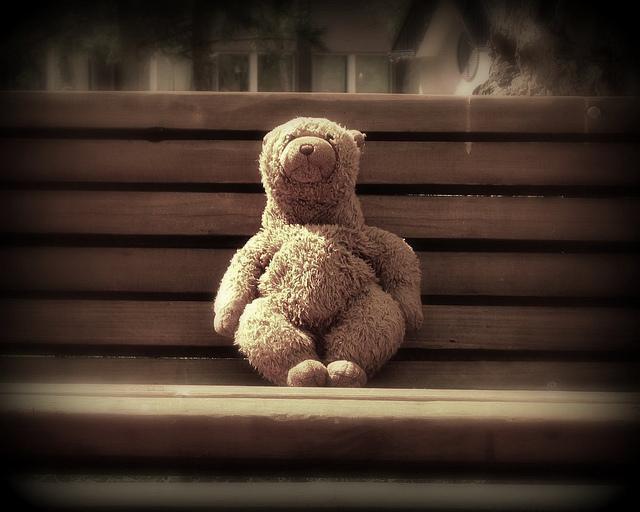How many benches are there?
Give a very brief answer. 1. 